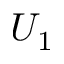<formula> <loc_0><loc_0><loc_500><loc_500>U _ { 1 }</formula> 